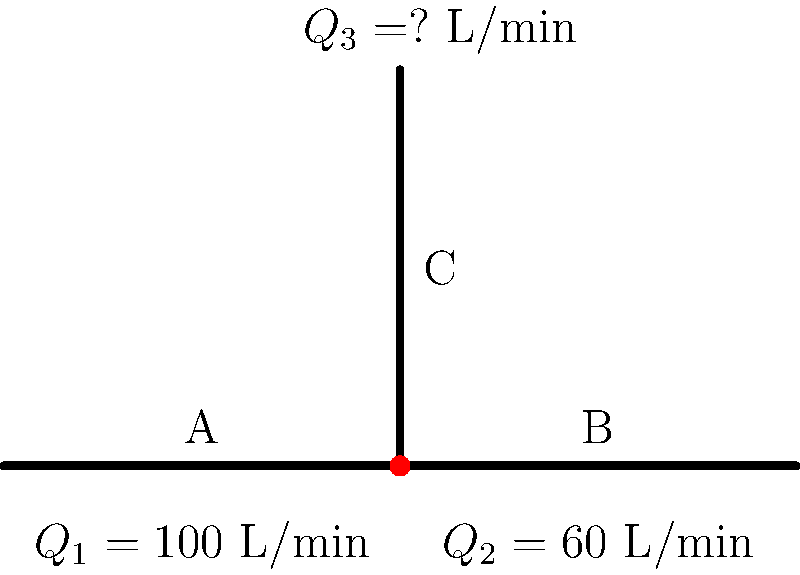In the municipal water system shown above, water flows from left to right. The flow rate in pipe A is 100 L/min, and the flow rate in pipe B is 60 L/min. Assuming no water accumulation at the junction, what is the flow rate $Q_3$ in pipe C? To solve this problem, we need to apply the principle of conservation of mass, which in this case translates to the conservation of water volume. At the junction point, the sum of all inflows must equal the sum of all outflows.

Step 1: Identify the known flow rates
- Pipe A (inflow): $Q_1 = 100$ L/min
- Pipe B (outflow): $Q_2 = 60$ L/min
- Pipe C (outflow): $Q_3 = $ unknown

Step 2: Apply the conservation principle
At the junction: Inflow = Outflow
$Q_1 = Q_2 + Q_3$

Step 3: Substitute the known values
$100 = 60 + Q_3$

Step 4: Solve for $Q_3$
$Q_3 = 100 - 60 = 40$ L/min

Therefore, the flow rate in pipe C is 40 L/min.
Answer: 40 L/min 